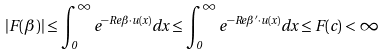Convert formula to latex. <formula><loc_0><loc_0><loc_500><loc_500>| F ( \beta ) | \leq \int _ { 0 } ^ { \infty } e ^ { - R e \beta \cdot u ( x ) } d x \leq \int _ { 0 } ^ { \infty } e ^ { - R e \beta ^ { \prime } \cdot u ( x ) } d x \leq F ( c ) < \infty</formula> 